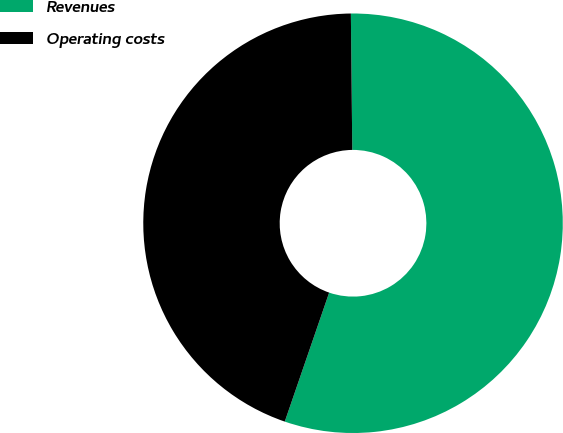Convert chart to OTSL. <chart><loc_0><loc_0><loc_500><loc_500><pie_chart><fcel>Revenues<fcel>Operating costs<nl><fcel>55.44%<fcel>44.56%<nl></chart> 